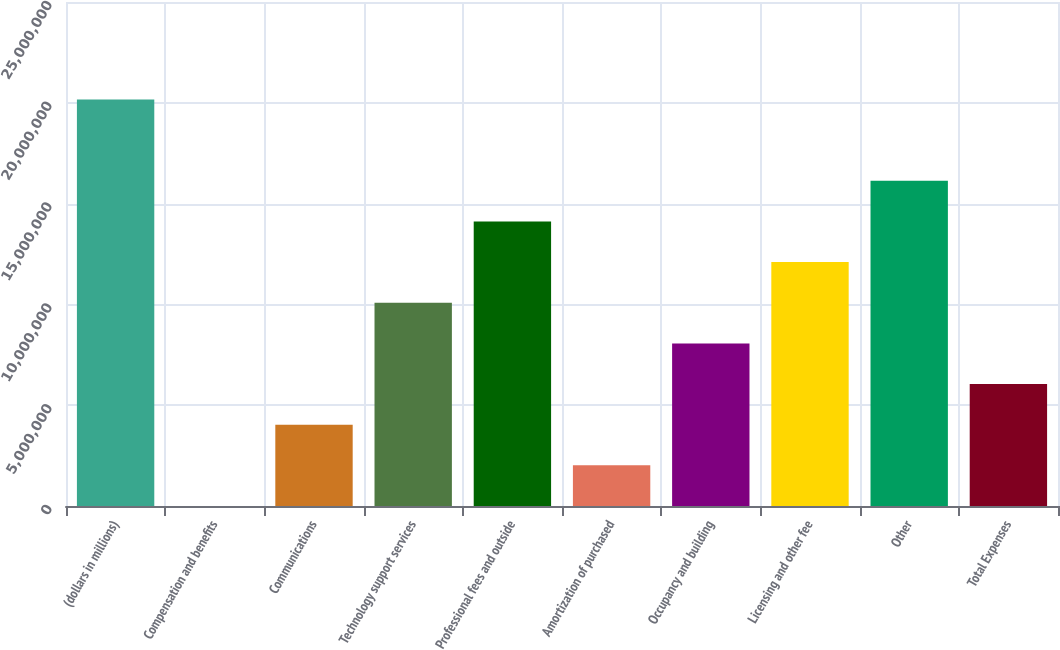<chart> <loc_0><loc_0><loc_500><loc_500><bar_chart><fcel>(dollars in millions)<fcel>Compensation and benefits<fcel>Communications<fcel>Technology support services<fcel>Professional fees and outside<fcel>Amortization of purchased<fcel>Occupancy and building<fcel>Licensing and other fee<fcel>Other<fcel>Total Expenses<nl><fcel>2.0162e+07<fcel>2<fcel>4.0324e+06<fcel>1.0081e+07<fcel>1.41134e+07<fcel>2.0162e+06<fcel>8.06481e+06<fcel>1.20972e+07<fcel>1.61296e+07<fcel>6.04861e+06<nl></chart> 